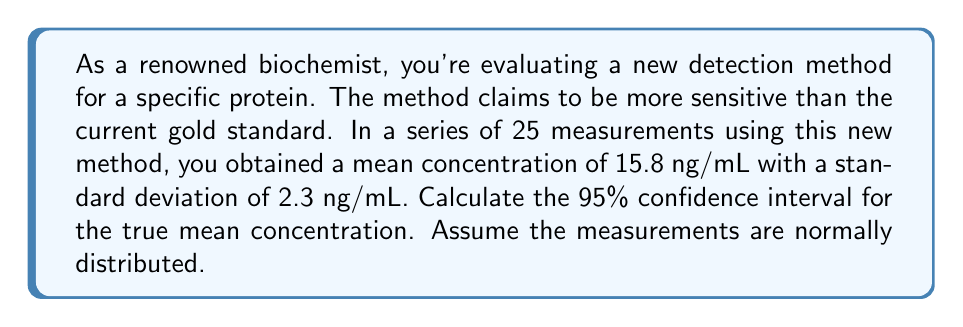Provide a solution to this math problem. To calculate the confidence interval, we'll use the formula:

$$\text{CI} = \bar{x} \pm t_{\alpha/2, n-1} \cdot \frac{s}{\sqrt{n}}$$

Where:
- $\bar{x}$ is the sample mean
- $t_{\alpha/2, n-1}$ is the t-value for a 95% confidence level with n-1 degrees of freedom
- $s$ is the sample standard deviation
- $n$ is the sample size

Given:
- $\bar{x} = 15.8$ ng/mL
- $s = 2.3$ ng/mL
- $n = 25$
- Confidence level = 95% (α = 0.05)

Steps:
1. Find the t-value:
   With 24 degrees of freedom (n-1) and α/2 = 0.025, $t_{0.025, 24} = 2.064$

2. Calculate the standard error of the mean:
   $$SE = \frac{s}{\sqrt{n}} = \frac{2.3}{\sqrt{25}} = 0.46$$

3. Calculate the margin of error:
   $$ME = t_{\alpha/2, n-1} \cdot SE = 2.064 \cdot 0.46 = 0.95$$

4. Calculate the confidence interval:
   $$CI = 15.8 \pm 0.95$$

Therefore, the 95% confidence interval is (14.85 ng/mL, 16.75 ng/mL).
Answer: The 95% confidence interval for the true mean concentration is (14.85 ng/mL, 16.75 ng/mL). 